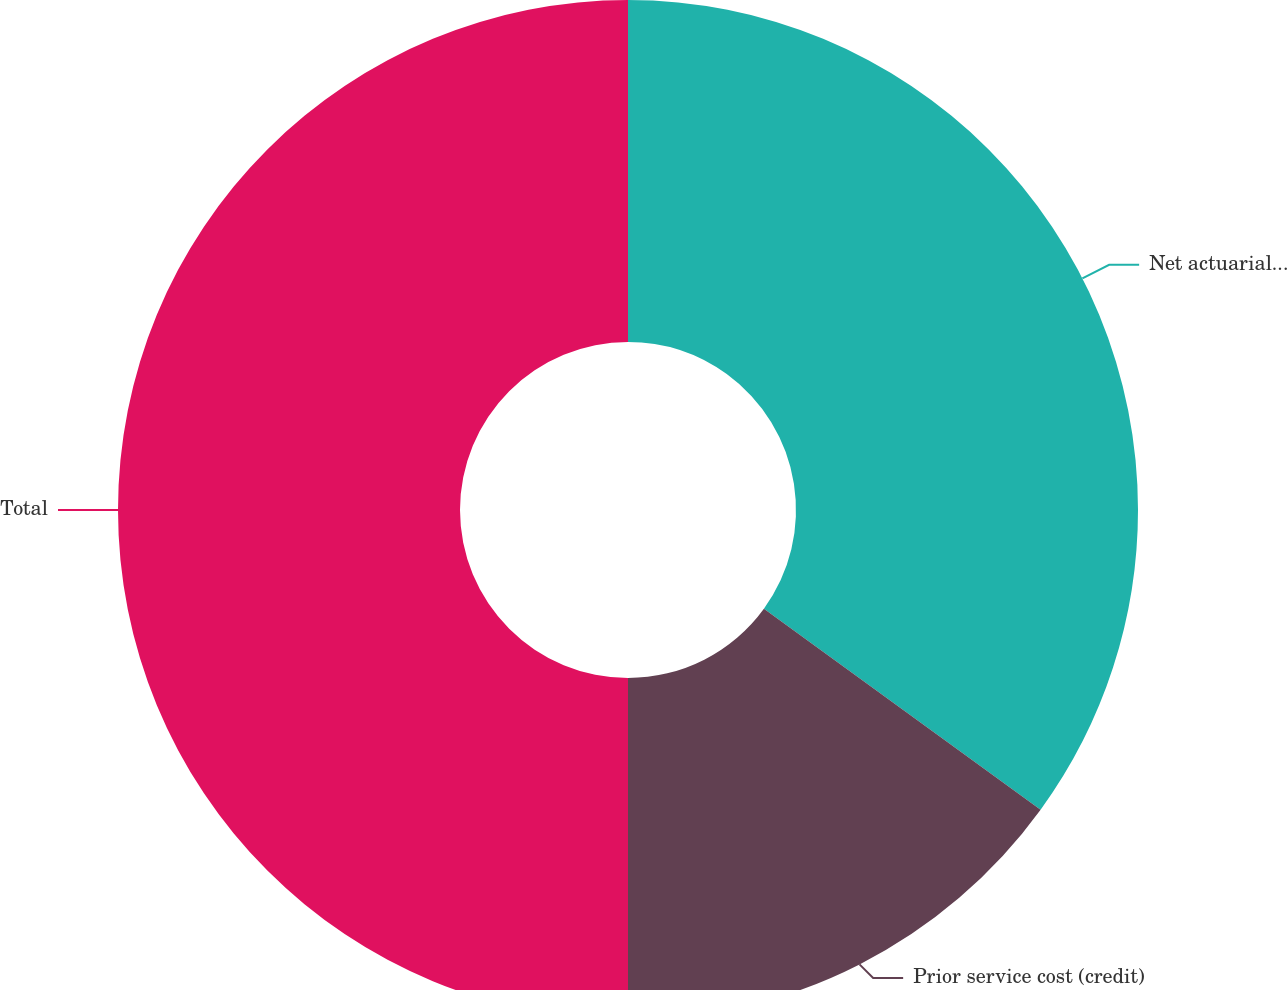<chart> <loc_0><loc_0><loc_500><loc_500><pie_chart><fcel>Net actuarial loss<fcel>Prior service cost (credit)<fcel>Total<nl><fcel>35.0%<fcel>15.0%<fcel>50.0%<nl></chart> 